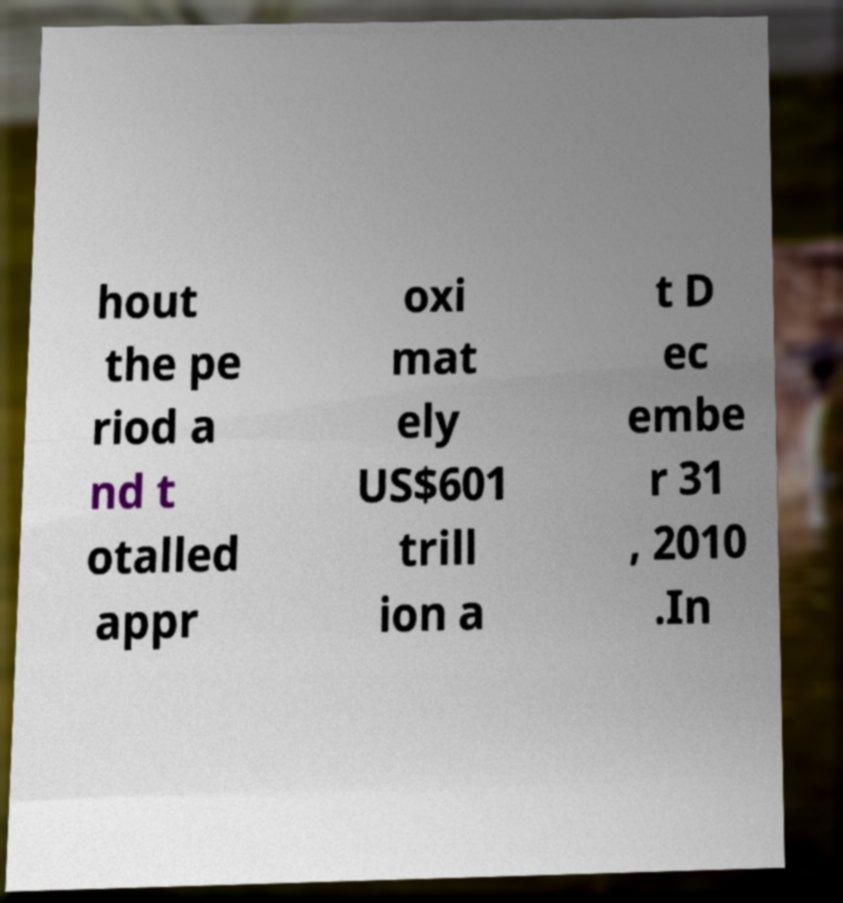Could you extract and type out the text from this image? hout the pe riod a nd t otalled appr oxi mat ely US$601 trill ion a t D ec embe r 31 , 2010 .In 